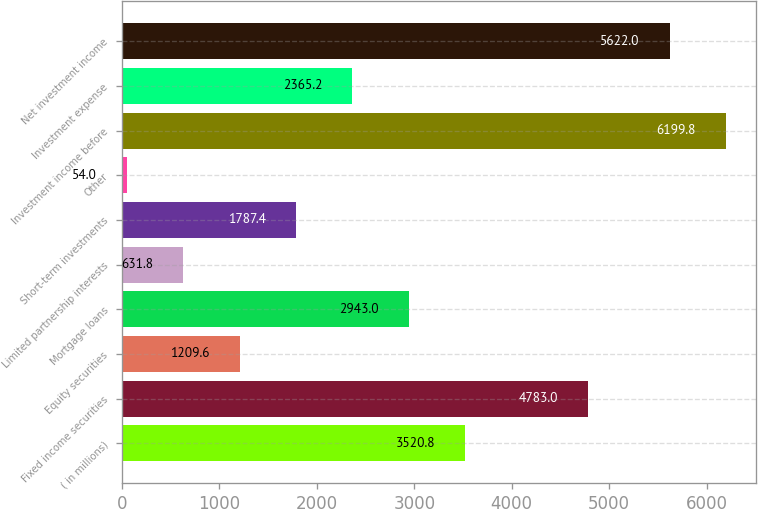Convert chart. <chart><loc_0><loc_0><loc_500><loc_500><bar_chart><fcel>( in millions)<fcel>Fixed income securities<fcel>Equity securities<fcel>Mortgage loans<fcel>Limited partnership interests<fcel>Short-term investments<fcel>Other<fcel>Investment income before<fcel>Investment expense<fcel>Net investment income<nl><fcel>3520.8<fcel>4783<fcel>1209.6<fcel>2943<fcel>631.8<fcel>1787.4<fcel>54<fcel>6199.8<fcel>2365.2<fcel>5622<nl></chart> 